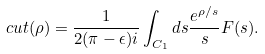<formula> <loc_0><loc_0><loc_500><loc_500>c u t ( \rho ) = \frac { 1 } { 2 ( \pi - \epsilon ) i } \int _ { C _ { 1 } } d s \frac { e ^ { \rho / s } } { s } F ( s ) .</formula> 